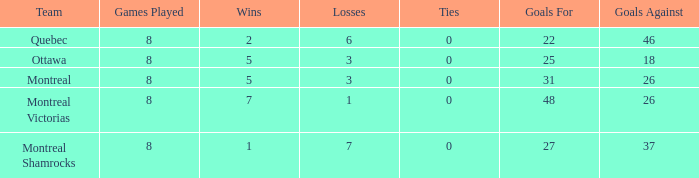For teams with fewer than 5 wins, goals against over 37, and fewer than 8 games played, what is the average number of ties? None. 